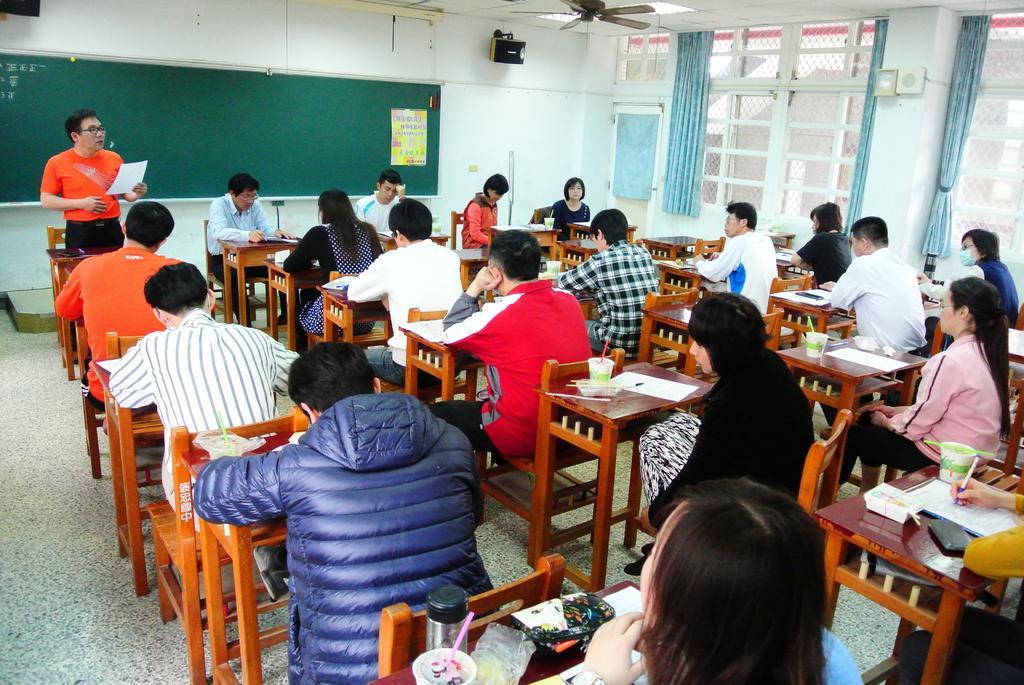Could you give a brief overview of what you see in this image? in the picture we can see a class room,in which all the students are sitting in the chair in front if there desk,on the desk we can see different items such as paper,water bottles,pens e. t. c. here in the picture we can see fan,board,and a person standing and reading something. 